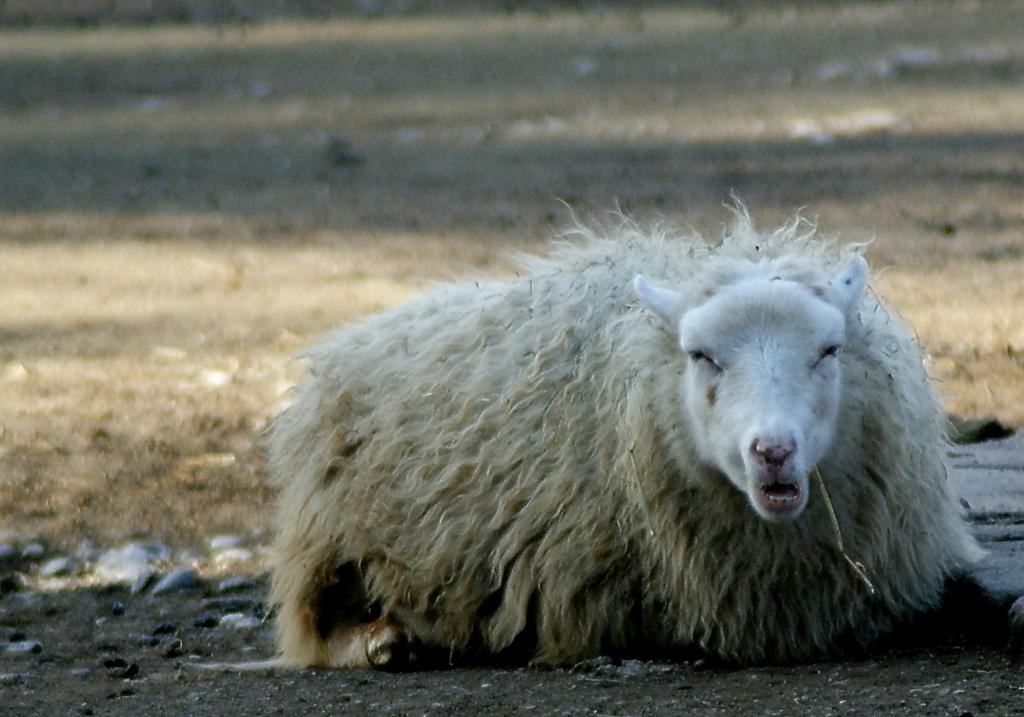What type of animal is in the front of the image? The type of animal cannot be determined from the provided facts. What can be seen on the ground in the background of the image? There is dry grass on the ground in the background. What is located on the ground in the center of the image? The objects on the ground in the center of the image cannot be identified from the provided facts. What type of quartz can be seen in the image? There is no quartz present in the image. How many ants are visible in the image? There is no mention of ants in the provided facts, so it cannot be determined if any are present in the image. 